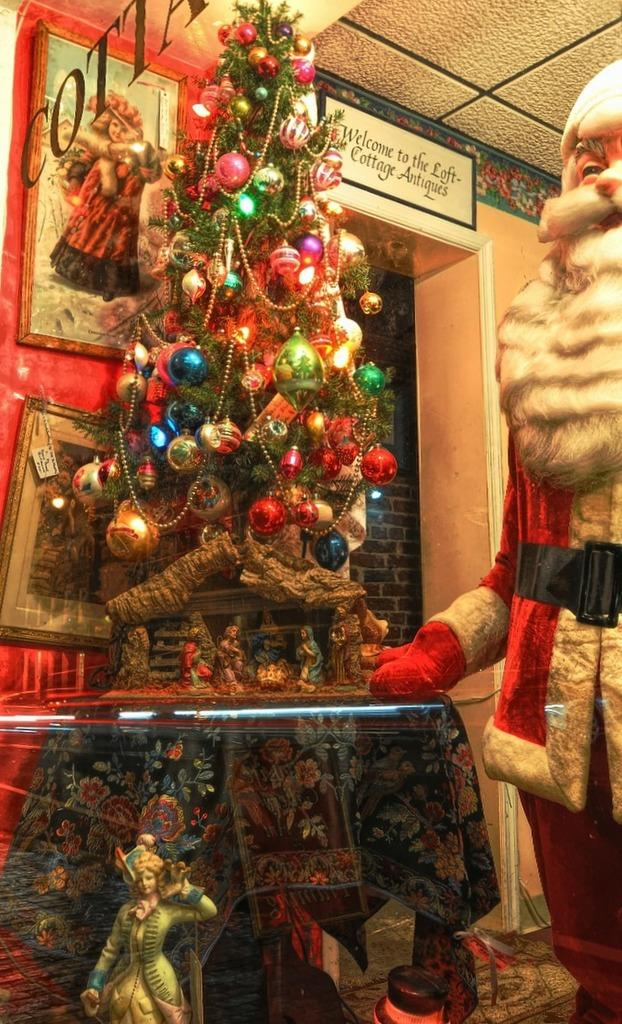What is located on the right side of the image? There is a statue on the right side of the image. What other decorative element can be seen in the image? There is a decorative tree in the image. What type of coat is the uncle wearing in the image? There is no uncle or coat present in the image. How many drops of water can be seen falling from the decorative tree in the image? There are no drops of water visible in the image, as it only features a statue and a decorative tree. 